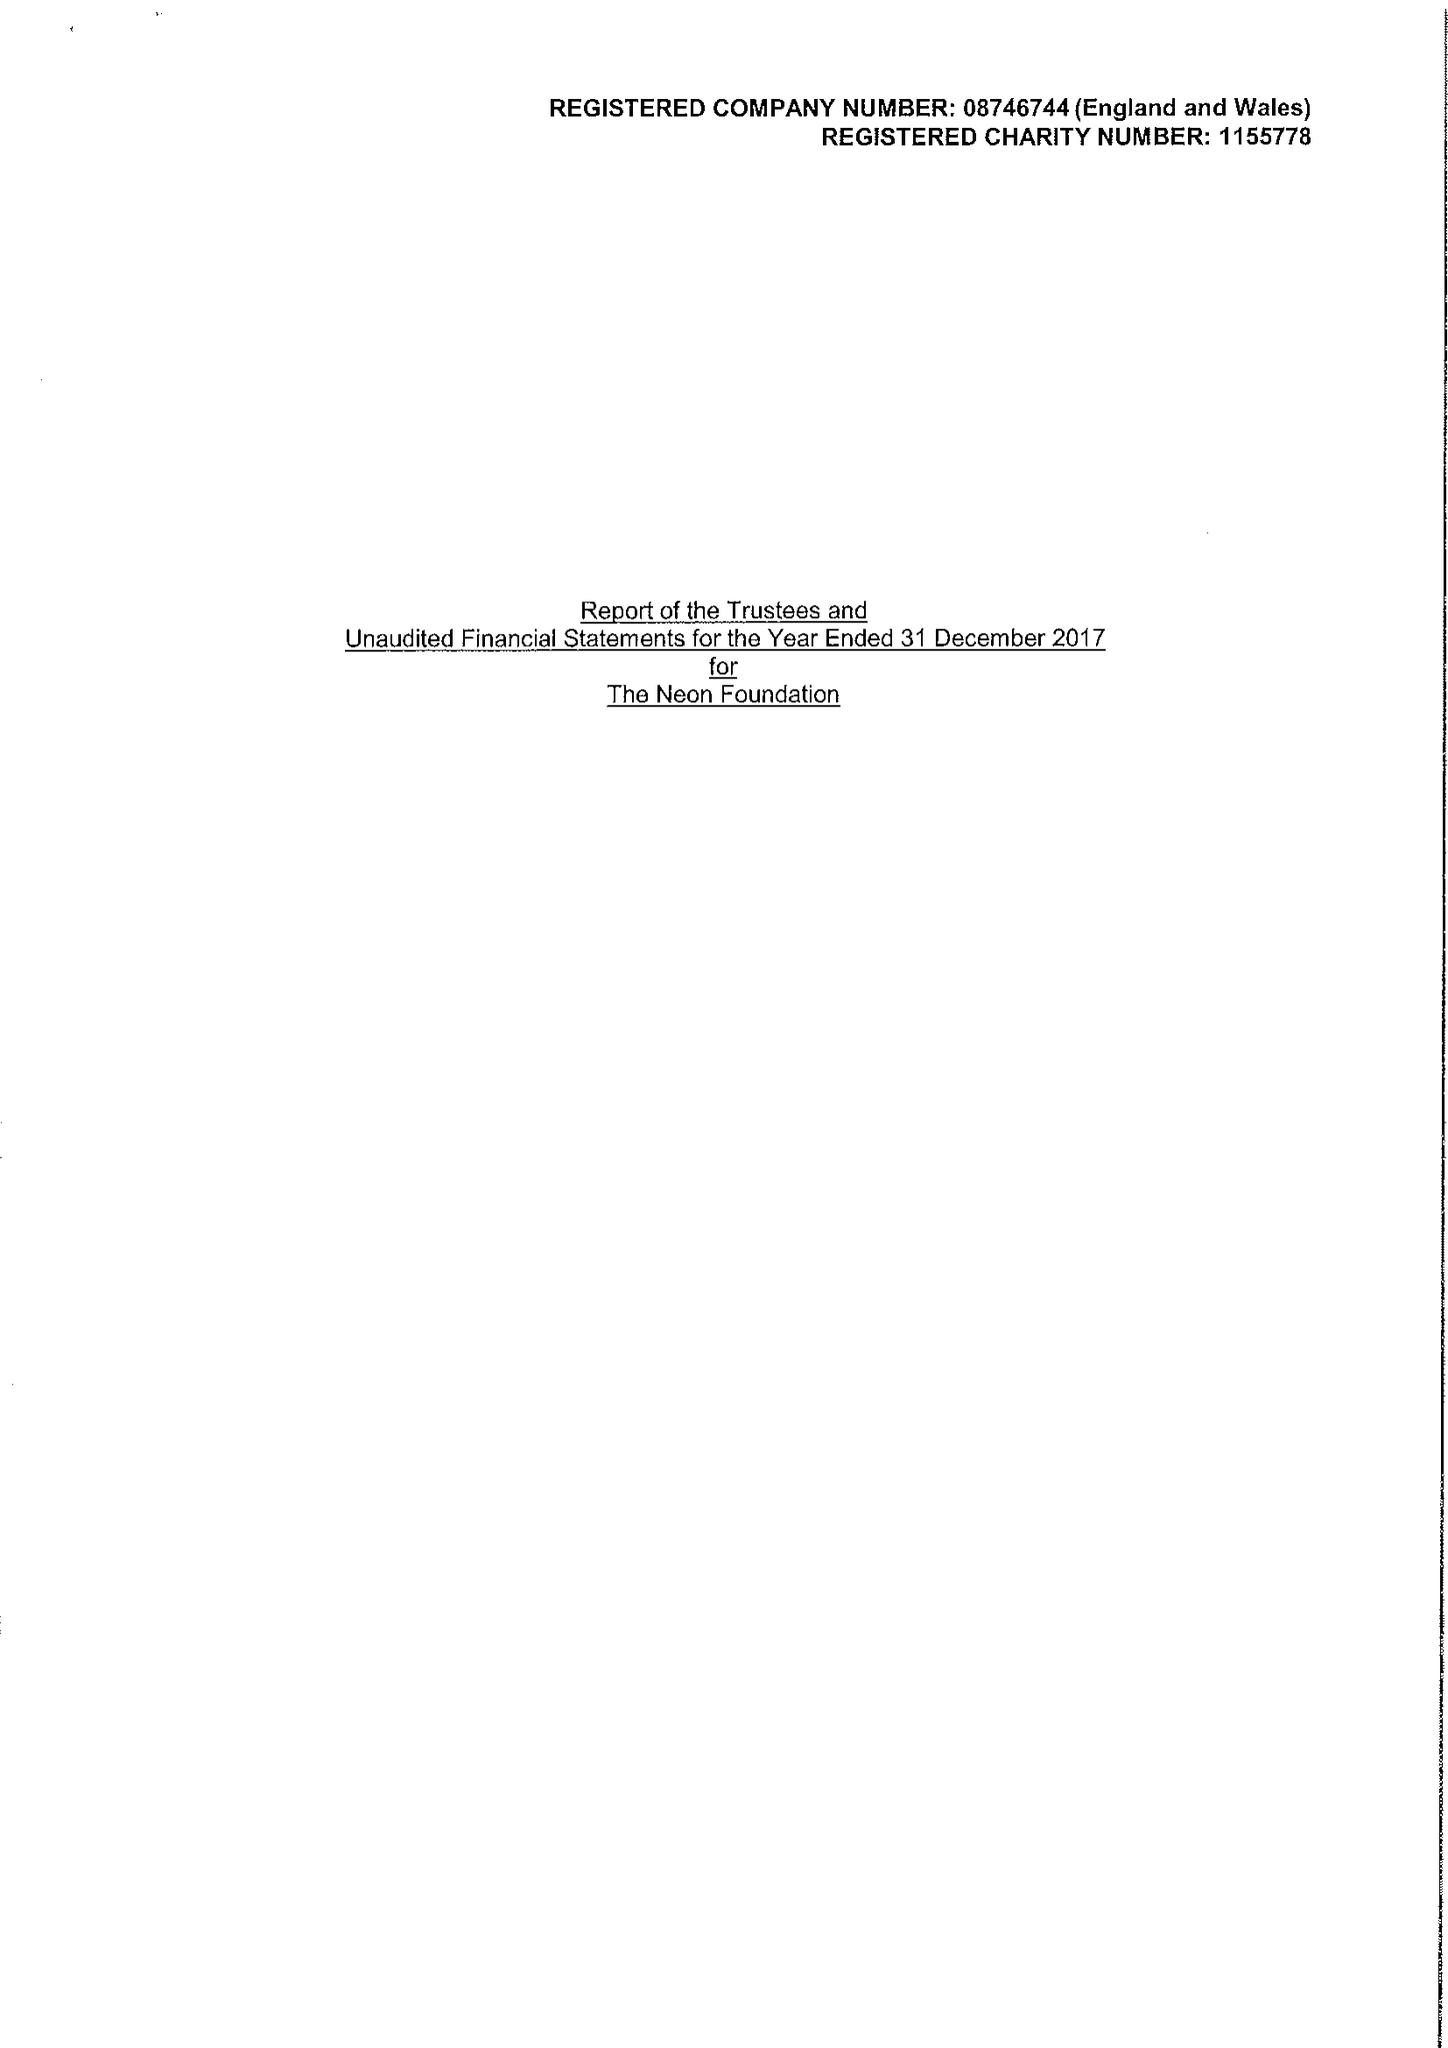What is the value for the charity_name?
Answer the question using a single word or phrase. The Neon Foundation 